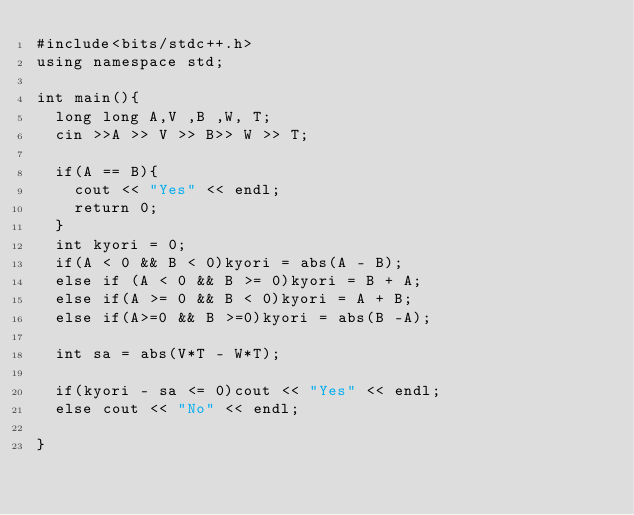Convert code to text. <code><loc_0><loc_0><loc_500><loc_500><_C++_>#include<bits/stdc++.h>
using namespace std;

int main(){
  long long A,V ,B ,W, T;
  cin >>A >> V >> B>> W >> T;
  
  if(A == B){
    cout << "Yes" << endl;
    return 0;
  }
  int kyori = 0;
  if(A < 0 && B < 0)kyori = abs(A - B);
  else if (A < 0 && B >= 0)kyori = B + A;
  else if(A >= 0 && B < 0)kyori = A + B;
  else if(A>=0 && B >=0)kyori = abs(B -A);
  
  int sa = abs(V*T - W*T);
  
  if(kyori - sa <= 0)cout << "Yes" << endl;
  else cout << "No" << endl;
  
}</code> 